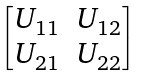<formula> <loc_0><loc_0><loc_500><loc_500>\begin{bmatrix} U _ { 1 1 } & U _ { 1 2 } \\ U _ { 2 1 } & U _ { 2 2 } \end{bmatrix}</formula> 